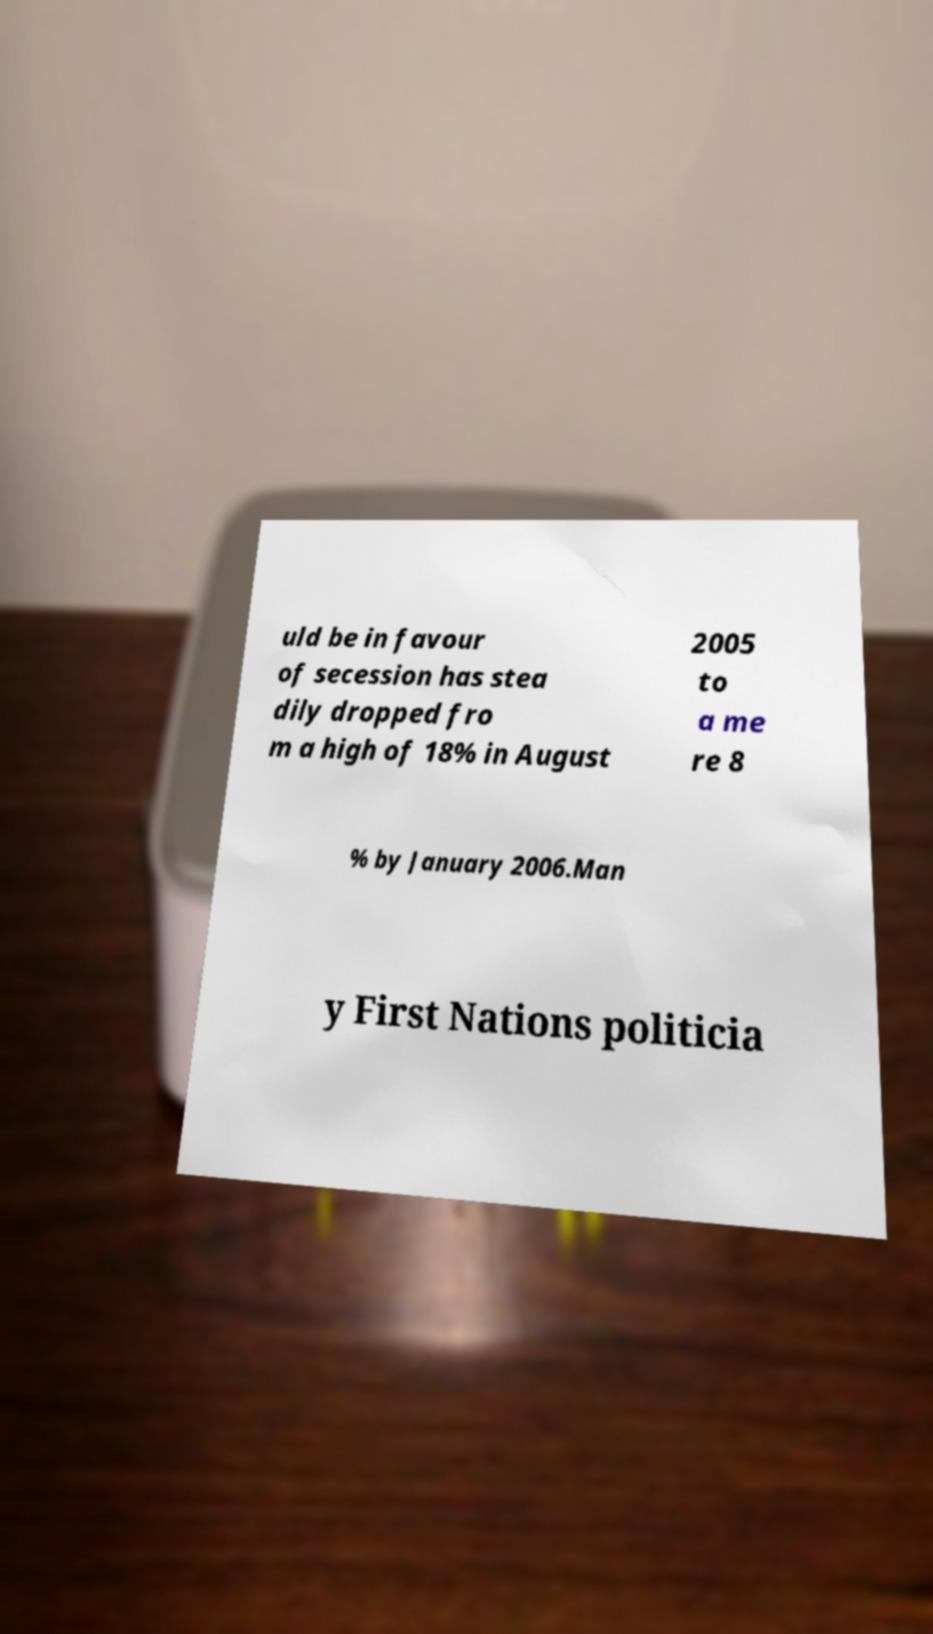Could you extract and type out the text from this image? uld be in favour of secession has stea dily dropped fro m a high of 18% in August 2005 to a me re 8 % by January 2006.Man y First Nations politicia 